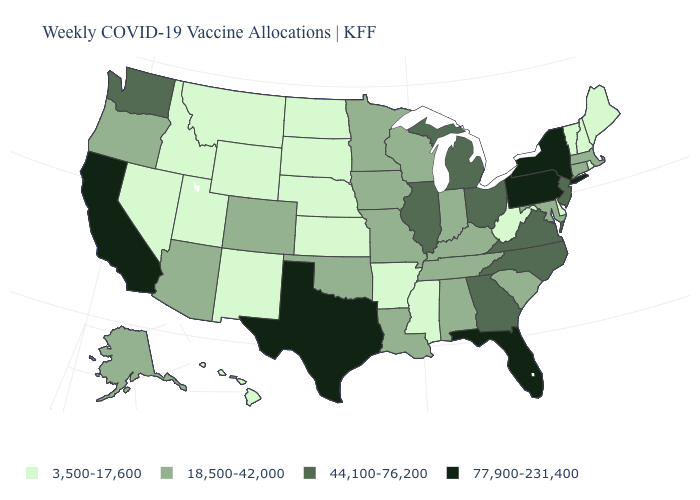What is the value of Rhode Island?
Be succinct. 3,500-17,600. Does the first symbol in the legend represent the smallest category?
Write a very short answer. Yes. Name the states that have a value in the range 77,900-231,400?
Short answer required. California, Florida, New York, Pennsylvania, Texas. What is the value of New Mexico?
Write a very short answer. 3,500-17,600. What is the value of South Dakota?
Keep it brief. 3,500-17,600. Does Illinois have the lowest value in the MidWest?
Short answer required. No. What is the value of Rhode Island?
Give a very brief answer. 3,500-17,600. What is the value of Missouri?
Write a very short answer. 18,500-42,000. What is the highest value in the West ?
Give a very brief answer. 77,900-231,400. Among the states that border Connecticut , does Rhode Island have the highest value?
Answer briefly. No. Name the states that have a value in the range 44,100-76,200?
Keep it brief. Georgia, Illinois, Michigan, New Jersey, North Carolina, Ohio, Virginia, Washington. Does Nevada have the same value as Virginia?
Answer briefly. No. How many symbols are there in the legend?
Give a very brief answer. 4. What is the value of North Dakota?
Give a very brief answer. 3,500-17,600. Does Ohio have the highest value in the MidWest?
Quick response, please. Yes. 